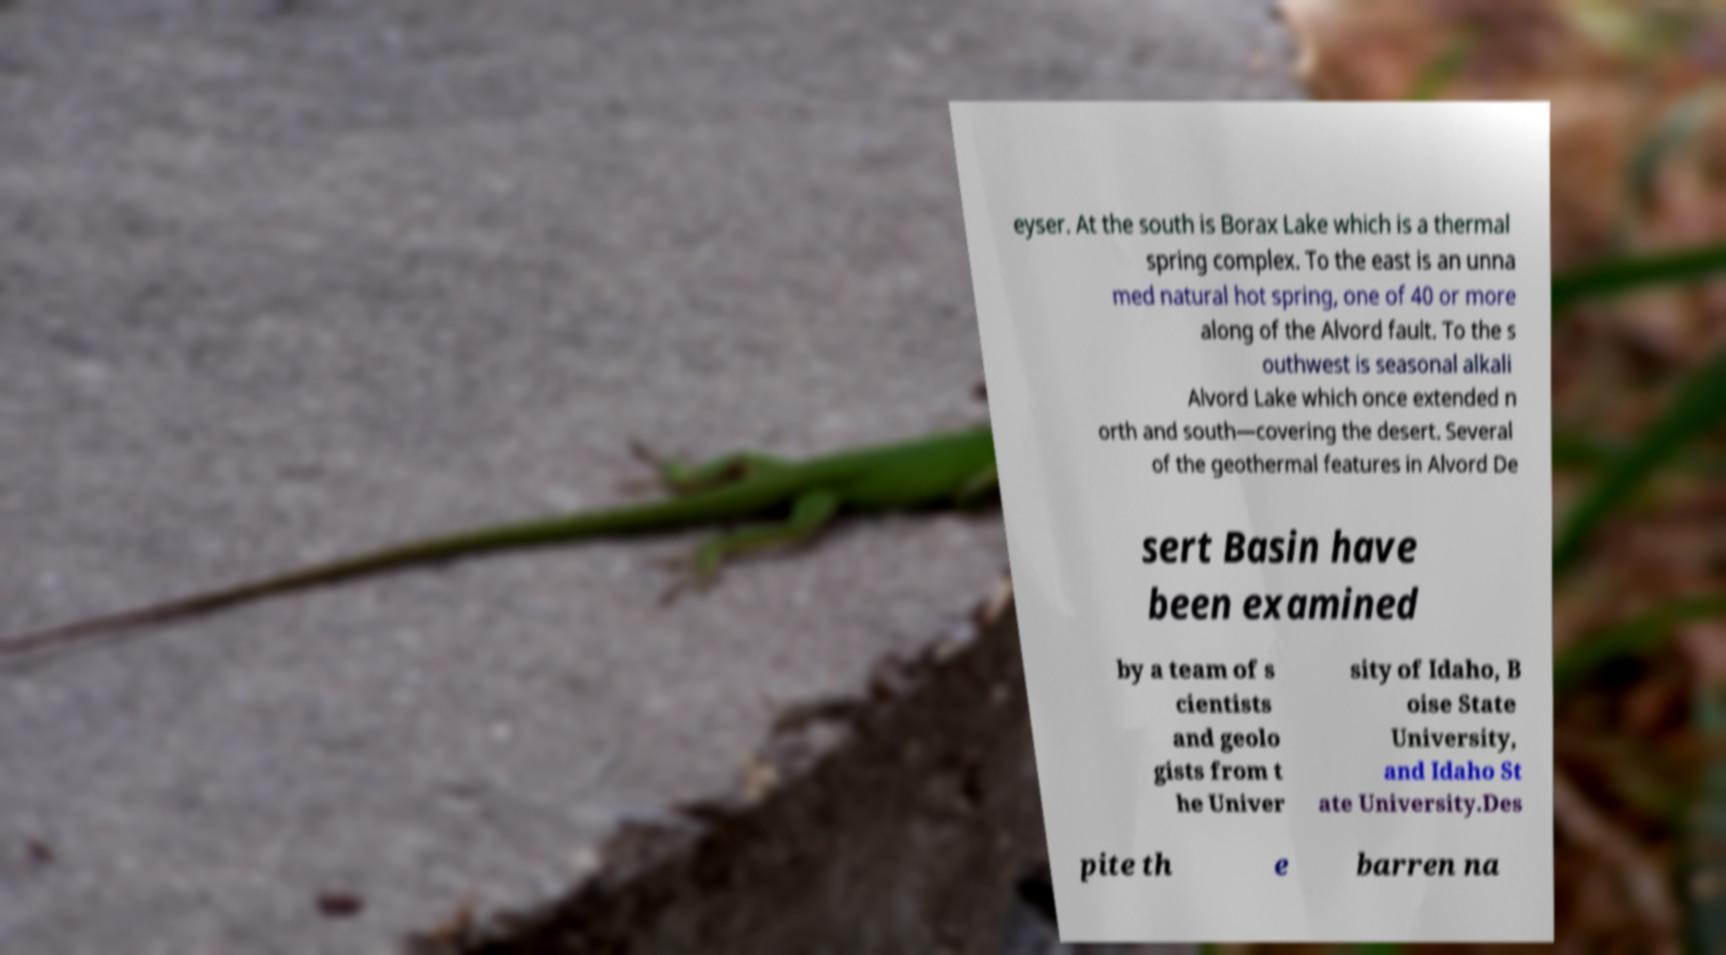For documentation purposes, I need the text within this image transcribed. Could you provide that? eyser. At the south is Borax Lake which is a thermal spring complex. To the east is an unna med natural hot spring, one of 40 or more along of the Alvord fault. To the s outhwest is seasonal alkali Alvord Lake which once extended n orth and south—covering the desert. Several of the geothermal features in Alvord De sert Basin have been examined by a team of s cientists and geolo gists from t he Univer sity of Idaho, B oise State University, and Idaho St ate University.Des pite th e barren na 